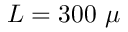<formula> <loc_0><loc_0><loc_500><loc_500>L = 3 0 0 \mu</formula> 